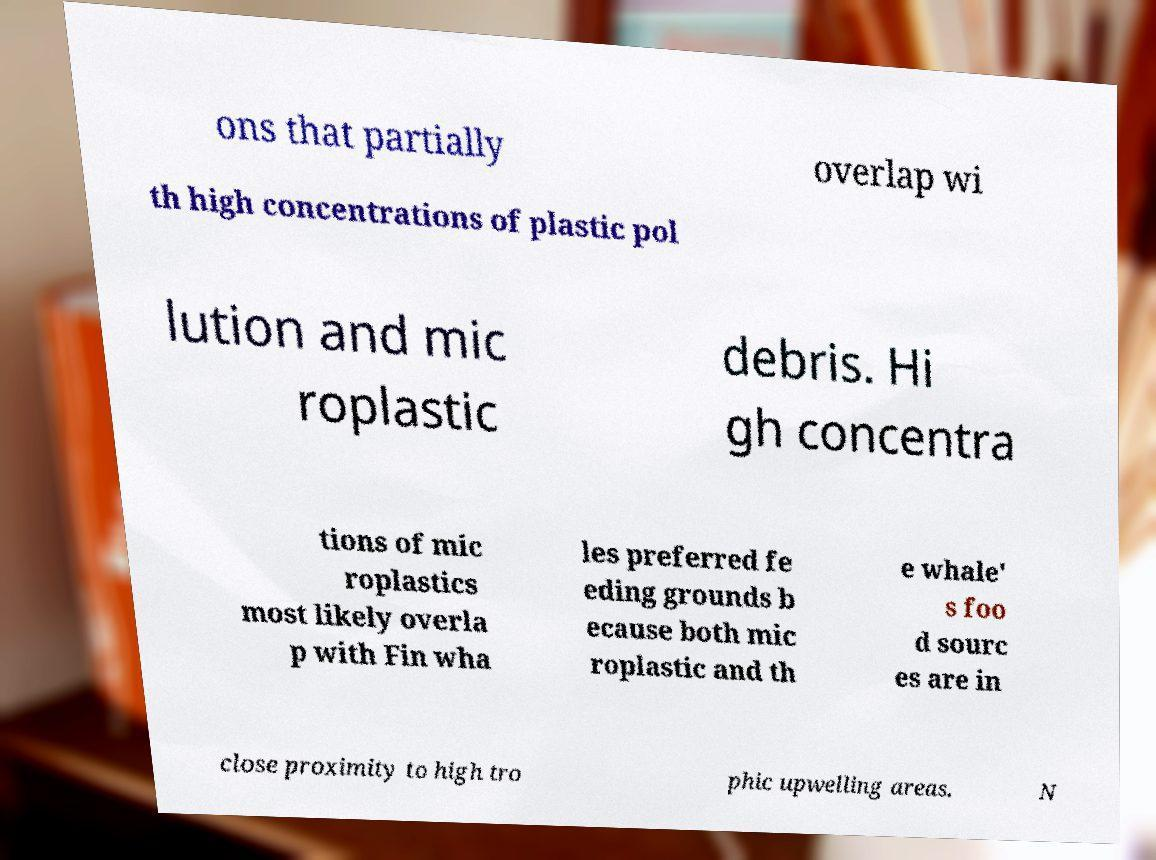Please identify and transcribe the text found in this image. ons that partially overlap wi th high concentrations of plastic pol lution and mic roplastic debris. Hi gh concentra tions of mic roplastics most likely overla p with Fin wha les preferred fe eding grounds b ecause both mic roplastic and th e whale' s foo d sourc es are in close proximity to high tro phic upwelling areas. N 